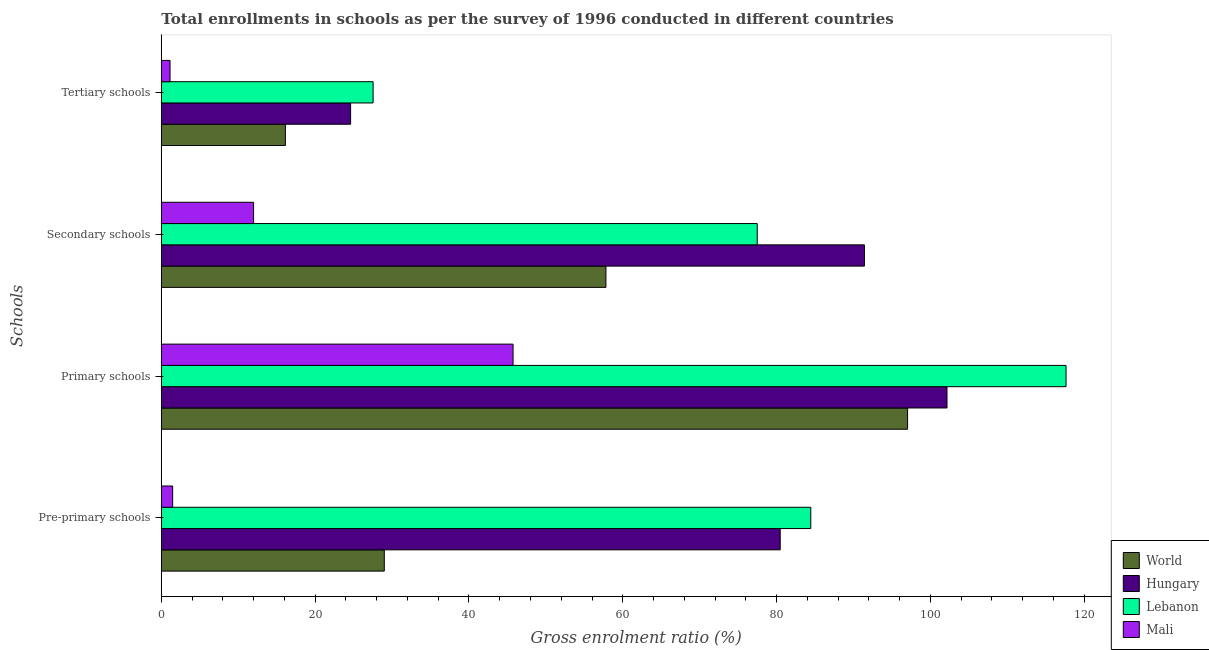How many groups of bars are there?
Provide a short and direct response. 4. Are the number of bars per tick equal to the number of legend labels?
Provide a short and direct response. Yes. Are the number of bars on each tick of the Y-axis equal?
Offer a terse response. Yes. How many bars are there on the 1st tick from the top?
Your answer should be very brief. 4. How many bars are there on the 1st tick from the bottom?
Give a very brief answer. 4. What is the label of the 2nd group of bars from the top?
Your response must be concise. Secondary schools. What is the gross enrolment ratio in primary schools in Hungary?
Provide a short and direct response. 102.16. Across all countries, what is the maximum gross enrolment ratio in secondary schools?
Offer a terse response. 91.43. Across all countries, what is the minimum gross enrolment ratio in primary schools?
Provide a short and direct response. 45.74. In which country was the gross enrolment ratio in tertiary schools maximum?
Make the answer very short. Lebanon. In which country was the gross enrolment ratio in tertiary schools minimum?
Provide a succinct answer. Mali. What is the total gross enrolment ratio in pre-primary schools in the graph?
Offer a very short reply. 195.39. What is the difference between the gross enrolment ratio in primary schools in Lebanon and that in Hungary?
Keep it short and to the point. 15.48. What is the difference between the gross enrolment ratio in primary schools in Mali and the gross enrolment ratio in pre-primary schools in Hungary?
Ensure brevity in your answer.  -34.74. What is the average gross enrolment ratio in pre-primary schools per country?
Keep it short and to the point. 48.85. What is the difference between the gross enrolment ratio in tertiary schools and gross enrolment ratio in primary schools in Hungary?
Your answer should be very brief. -77.54. In how many countries, is the gross enrolment ratio in pre-primary schools greater than 24 %?
Offer a terse response. 3. What is the ratio of the gross enrolment ratio in primary schools in Lebanon to that in Hungary?
Make the answer very short. 1.15. Is the gross enrolment ratio in secondary schools in World less than that in Hungary?
Provide a succinct answer. Yes. What is the difference between the highest and the second highest gross enrolment ratio in secondary schools?
Provide a succinct answer. 13.94. What is the difference between the highest and the lowest gross enrolment ratio in tertiary schools?
Offer a terse response. 26.4. In how many countries, is the gross enrolment ratio in primary schools greater than the average gross enrolment ratio in primary schools taken over all countries?
Make the answer very short. 3. Is it the case that in every country, the sum of the gross enrolment ratio in pre-primary schools and gross enrolment ratio in secondary schools is greater than the sum of gross enrolment ratio in tertiary schools and gross enrolment ratio in primary schools?
Give a very brief answer. No. What does the 3rd bar from the top in Secondary schools represents?
Offer a terse response. Hungary. What does the 3rd bar from the bottom in Pre-primary schools represents?
Keep it short and to the point. Lebanon. How many bars are there?
Your answer should be compact. 16. How many countries are there in the graph?
Make the answer very short. 4. What is the difference between two consecutive major ticks on the X-axis?
Offer a terse response. 20. Does the graph contain grids?
Offer a very short reply. No. Where does the legend appear in the graph?
Your answer should be very brief. Bottom right. How many legend labels are there?
Your response must be concise. 4. What is the title of the graph?
Make the answer very short. Total enrollments in schools as per the survey of 1996 conducted in different countries. Does "Serbia" appear as one of the legend labels in the graph?
Give a very brief answer. No. What is the label or title of the X-axis?
Ensure brevity in your answer.  Gross enrolment ratio (%). What is the label or title of the Y-axis?
Your response must be concise. Schools. What is the Gross enrolment ratio (%) in World in Pre-primary schools?
Offer a very short reply. 28.99. What is the Gross enrolment ratio (%) of Hungary in Pre-primary schools?
Offer a very short reply. 80.47. What is the Gross enrolment ratio (%) of Lebanon in Pre-primary schools?
Provide a short and direct response. 84.45. What is the Gross enrolment ratio (%) of Mali in Pre-primary schools?
Make the answer very short. 1.47. What is the Gross enrolment ratio (%) in World in Primary schools?
Offer a very short reply. 97.03. What is the Gross enrolment ratio (%) of Hungary in Primary schools?
Your response must be concise. 102.16. What is the Gross enrolment ratio (%) in Lebanon in Primary schools?
Offer a very short reply. 117.64. What is the Gross enrolment ratio (%) in Mali in Primary schools?
Your response must be concise. 45.74. What is the Gross enrolment ratio (%) of World in Secondary schools?
Your answer should be very brief. 57.81. What is the Gross enrolment ratio (%) of Hungary in Secondary schools?
Ensure brevity in your answer.  91.43. What is the Gross enrolment ratio (%) in Lebanon in Secondary schools?
Your answer should be compact. 77.48. What is the Gross enrolment ratio (%) in Mali in Secondary schools?
Make the answer very short. 11.99. What is the Gross enrolment ratio (%) of World in Tertiary schools?
Provide a short and direct response. 16.13. What is the Gross enrolment ratio (%) of Hungary in Tertiary schools?
Your response must be concise. 24.61. What is the Gross enrolment ratio (%) of Lebanon in Tertiary schools?
Offer a terse response. 27.54. What is the Gross enrolment ratio (%) of Mali in Tertiary schools?
Ensure brevity in your answer.  1.14. Across all Schools, what is the maximum Gross enrolment ratio (%) in World?
Provide a succinct answer. 97.03. Across all Schools, what is the maximum Gross enrolment ratio (%) of Hungary?
Give a very brief answer. 102.16. Across all Schools, what is the maximum Gross enrolment ratio (%) in Lebanon?
Provide a short and direct response. 117.64. Across all Schools, what is the maximum Gross enrolment ratio (%) of Mali?
Provide a short and direct response. 45.74. Across all Schools, what is the minimum Gross enrolment ratio (%) in World?
Keep it short and to the point. 16.13. Across all Schools, what is the minimum Gross enrolment ratio (%) in Hungary?
Make the answer very short. 24.61. Across all Schools, what is the minimum Gross enrolment ratio (%) in Lebanon?
Ensure brevity in your answer.  27.54. Across all Schools, what is the minimum Gross enrolment ratio (%) in Mali?
Provide a short and direct response. 1.14. What is the total Gross enrolment ratio (%) of World in the graph?
Give a very brief answer. 199.97. What is the total Gross enrolment ratio (%) in Hungary in the graph?
Provide a succinct answer. 298.67. What is the total Gross enrolment ratio (%) in Lebanon in the graph?
Your response must be concise. 307.11. What is the total Gross enrolment ratio (%) of Mali in the graph?
Your answer should be very brief. 60.34. What is the difference between the Gross enrolment ratio (%) in World in Pre-primary schools and that in Primary schools?
Your answer should be very brief. -68.04. What is the difference between the Gross enrolment ratio (%) in Hungary in Pre-primary schools and that in Primary schools?
Offer a terse response. -21.69. What is the difference between the Gross enrolment ratio (%) in Lebanon in Pre-primary schools and that in Primary schools?
Give a very brief answer. -33.19. What is the difference between the Gross enrolment ratio (%) in Mali in Pre-primary schools and that in Primary schools?
Provide a succinct answer. -44.26. What is the difference between the Gross enrolment ratio (%) of World in Pre-primary schools and that in Secondary schools?
Provide a succinct answer. -28.82. What is the difference between the Gross enrolment ratio (%) of Hungary in Pre-primary schools and that in Secondary schools?
Make the answer very short. -10.95. What is the difference between the Gross enrolment ratio (%) in Lebanon in Pre-primary schools and that in Secondary schools?
Your answer should be very brief. 6.96. What is the difference between the Gross enrolment ratio (%) of Mali in Pre-primary schools and that in Secondary schools?
Offer a terse response. -10.52. What is the difference between the Gross enrolment ratio (%) in World in Pre-primary schools and that in Tertiary schools?
Your answer should be very brief. 12.86. What is the difference between the Gross enrolment ratio (%) of Hungary in Pre-primary schools and that in Tertiary schools?
Give a very brief answer. 55.86. What is the difference between the Gross enrolment ratio (%) of Lebanon in Pre-primary schools and that in Tertiary schools?
Your answer should be compact. 56.91. What is the difference between the Gross enrolment ratio (%) of Mali in Pre-primary schools and that in Tertiary schools?
Make the answer very short. 0.34. What is the difference between the Gross enrolment ratio (%) in World in Primary schools and that in Secondary schools?
Your response must be concise. 39.22. What is the difference between the Gross enrolment ratio (%) in Hungary in Primary schools and that in Secondary schools?
Offer a very short reply. 10.73. What is the difference between the Gross enrolment ratio (%) in Lebanon in Primary schools and that in Secondary schools?
Your answer should be compact. 40.15. What is the difference between the Gross enrolment ratio (%) in Mali in Primary schools and that in Secondary schools?
Offer a very short reply. 33.74. What is the difference between the Gross enrolment ratio (%) of World in Primary schools and that in Tertiary schools?
Your answer should be compact. 80.9. What is the difference between the Gross enrolment ratio (%) of Hungary in Primary schools and that in Tertiary schools?
Offer a very short reply. 77.54. What is the difference between the Gross enrolment ratio (%) in Lebanon in Primary schools and that in Tertiary schools?
Offer a very short reply. 90.1. What is the difference between the Gross enrolment ratio (%) in Mali in Primary schools and that in Tertiary schools?
Your answer should be very brief. 44.6. What is the difference between the Gross enrolment ratio (%) in World in Secondary schools and that in Tertiary schools?
Your answer should be very brief. 41.68. What is the difference between the Gross enrolment ratio (%) of Hungary in Secondary schools and that in Tertiary schools?
Your response must be concise. 66.81. What is the difference between the Gross enrolment ratio (%) of Lebanon in Secondary schools and that in Tertiary schools?
Provide a short and direct response. 49.95. What is the difference between the Gross enrolment ratio (%) in Mali in Secondary schools and that in Tertiary schools?
Your answer should be very brief. 10.86. What is the difference between the Gross enrolment ratio (%) in World in Pre-primary schools and the Gross enrolment ratio (%) in Hungary in Primary schools?
Offer a terse response. -73.16. What is the difference between the Gross enrolment ratio (%) in World in Pre-primary schools and the Gross enrolment ratio (%) in Lebanon in Primary schools?
Give a very brief answer. -88.64. What is the difference between the Gross enrolment ratio (%) in World in Pre-primary schools and the Gross enrolment ratio (%) in Mali in Primary schools?
Your answer should be very brief. -16.74. What is the difference between the Gross enrolment ratio (%) of Hungary in Pre-primary schools and the Gross enrolment ratio (%) of Lebanon in Primary schools?
Make the answer very short. -37.17. What is the difference between the Gross enrolment ratio (%) of Hungary in Pre-primary schools and the Gross enrolment ratio (%) of Mali in Primary schools?
Make the answer very short. 34.74. What is the difference between the Gross enrolment ratio (%) of Lebanon in Pre-primary schools and the Gross enrolment ratio (%) of Mali in Primary schools?
Provide a short and direct response. 38.71. What is the difference between the Gross enrolment ratio (%) of World in Pre-primary schools and the Gross enrolment ratio (%) of Hungary in Secondary schools?
Keep it short and to the point. -62.43. What is the difference between the Gross enrolment ratio (%) in World in Pre-primary schools and the Gross enrolment ratio (%) in Lebanon in Secondary schools?
Make the answer very short. -48.49. What is the difference between the Gross enrolment ratio (%) in World in Pre-primary schools and the Gross enrolment ratio (%) in Mali in Secondary schools?
Make the answer very short. 17. What is the difference between the Gross enrolment ratio (%) of Hungary in Pre-primary schools and the Gross enrolment ratio (%) of Lebanon in Secondary schools?
Make the answer very short. 2.99. What is the difference between the Gross enrolment ratio (%) in Hungary in Pre-primary schools and the Gross enrolment ratio (%) in Mali in Secondary schools?
Your answer should be very brief. 68.48. What is the difference between the Gross enrolment ratio (%) in Lebanon in Pre-primary schools and the Gross enrolment ratio (%) in Mali in Secondary schools?
Provide a short and direct response. 72.45. What is the difference between the Gross enrolment ratio (%) in World in Pre-primary schools and the Gross enrolment ratio (%) in Hungary in Tertiary schools?
Make the answer very short. 4.38. What is the difference between the Gross enrolment ratio (%) in World in Pre-primary schools and the Gross enrolment ratio (%) in Lebanon in Tertiary schools?
Provide a short and direct response. 1.46. What is the difference between the Gross enrolment ratio (%) of World in Pre-primary schools and the Gross enrolment ratio (%) of Mali in Tertiary schools?
Keep it short and to the point. 27.86. What is the difference between the Gross enrolment ratio (%) in Hungary in Pre-primary schools and the Gross enrolment ratio (%) in Lebanon in Tertiary schools?
Provide a short and direct response. 52.93. What is the difference between the Gross enrolment ratio (%) in Hungary in Pre-primary schools and the Gross enrolment ratio (%) in Mali in Tertiary schools?
Ensure brevity in your answer.  79.34. What is the difference between the Gross enrolment ratio (%) in Lebanon in Pre-primary schools and the Gross enrolment ratio (%) in Mali in Tertiary schools?
Give a very brief answer. 83.31. What is the difference between the Gross enrolment ratio (%) in World in Primary schools and the Gross enrolment ratio (%) in Hungary in Secondary schools?
Keep it short and to the point. 5.61. What is the difference between the Gross enrolment ratio (%) in World in Primary schools and the Gross enrolment ratio (%) in Lebanon in Secondary schools?
Provide a short and direct response. 19.55. What is the difference between the Gross enrolment ratio (%) in World in Primary schools and the Gross enrolment ratio (%) in Mali in Secondary schools?
Your answer should be very brief. 85.04. What is the difference between the Gross enrolment ratio (%) of Hungary in Primary schools and the Gross enrolment ratio (%) of Lebanon in Secondary schools?
Provide a succinct answer. 24.67. What is the difference between the Gross enrolment ratio (%) of Hungary in Primary schools and the Gross enrolment ratio (%) of Mali in Secondary schools?
Offer a very short reply. 90.16. What is the difference between the Gross enrolment ratio (%) of Lebanon in Primary schools and the Gross enrolment ratio (%) of Mali in Secondary schools?
Ensure brevity in your answer.  105.64. What is the difference between the Gross enrolment ratio (%) in World in Primary schools and the Gross enrolment ratio (%) in Hungary in Tertiary schools?
Ensure brevity in your answer.  72.42. What is the difference between the Gross enrolment ratio (%) in World in Primary schools and the Gross enrolment ratio (%) in Lebanon in Tertiary schools?
Provide a short and direct response. 69.5. What is the difference between the Gross enrolment ratio (%) of World in Primary schools and the Gross enrolment ratio (%) of Mali in Tertiary schools?
Your answer should be very brief. 95.9. What is the difference between the Gross enrolment ratio (%) of Hungary in Primary schools and the Gross enrolment ratio (%) of Lebanon in Tertiary schools?
Your answer should be compact. 74.62. What is the difference between the Gross enrolment ratio (%) in Hungary in Primary schools and the Gross enrolment ratio (%) in Mali in Tertiary schools?
Your answer should be compact. 101.02. What is the difference between the Gross enrolment ratio (%) of Lebanon in Primary schools and the Gross enrolment ratio (%) of Mali in Tertiary schools?
Give a very brief answer. 116.5. What is the difference between the Gross enrolment ratio (%) of World in Secondary schools and the Gross enrolment ratio (%) of Hungary in Tertiary schools?
Give a very brief answer. 33.2. What is the difference between the Gross enrolment ratio (%) in World in Secondary schools and the Gross enrolment ratio (%) in Lebanon in Tertiary schools?
Offer a very short reply. 30.27. What is the difference between the Gross enrolment ratio (%) in World in Secondary schools and the Gross enrolment ratio (%) in Mali in Tertiary schools?
Make the answer very short. 56.68. What is the difference between the Gross enrolment ratio (%) in Hungary in Secondary schools and the Gross enrolment ratio (%) in Lebanon in Tertiary schools?
Offer a very short reply. 63.89. What is the difference between the Gross enrolment ratio (%) of Hungary in Secondary schools and the Gross enrolment ratio (%) of Mali in Tertiary schools?
Provide a short and direct response. 90.29. What is the difference between the Gross enrolment ratio (%) of Lebanon in Secondary schools and the Gross enrolment ratio (%) of Mali in Tertiary schools?
Provide a succinct answer. 76.35. What is the average Gross enrolment ratio (%) in World per Schools?
Keep it short and to the point. 49.99. What is the average Gross enrolment ratio (%) of Hungary per Schools?
Your answer should be compact. 74.67. What is the average Gross enrolment ratio (%) in Lebanon per Schools?
Your answer should be very brief. 76.78. What is the average Gross enrolment ratio (%) of Mali per Schools?
Offer a terse response. 15.08. What is the difference between the Gross enrolment ratio (%) in World and Gross enrolment ratio (%) in Hungary in Pre-primary schools?
Provide a short and direct response. -51.48. What is the difference between the Gross enrolment ratio (%) of World and Gross enrolment ratio (%) of Lebanon in Pre-primary schools?
Provide a succinct answer. -55.45. What is the difference between the Gross enrolment ratio (%) in World and Gross enrolment ratio (%) in Mali in Pre-primary schools?
Your response must be concise. 27.52. What is the difference between the Gross enrolment ratio (%) in Hungary and Gross enrolment ratio (%) in Lebanon in Pre-primary schools?
Make the answer very short. -3.98. What is the difference between the Gross enrolment ratio (%) in Hungary and Gross enrolment ratio (%) in Mali in Pre-primary schools?
Provide a succinct answer. 79. What is the difference between the Gross enrolment ratio (%) in Lebanon and Gross enrolment ratio (%) in Mali in Pre-primary schools?
Your answer should be very brief. 82.97. What is the difference between the Gross enrolment ratio (%) in World and Gross enrolment ratio (%) in Hungary in Primary schools?
Your answer should be compact. -5.12. What is the difference between the Gross enrolment ratio (%) in World and Gross enrolment ratio (%) in Lebanon in Primary schools?
Keep it short and to the point. -20.6. What is the difference between the Gross enrolment ratio (%) of World and Gross enrolment ratio (%) of Mali in Primary schools?
Give a very brief answer. 51.3. What is the difference between the Gross enrolment ratio (%) in Hungary and Gross enrolment ratio (%) in Lebanon in Primary schools?
Give a very brief answer. -15.48. What is the difference between the Gross enrolment ratio (%) of Hungary and Gross enrolment ratio (%) of Mali in Primary schools?
Make the answer very short. 56.42. What is the difference between the Gross enrolment ratio (%) of Lebanon and Gross enrolment ratio (%) of Mali in Primary schools?
Offer a terse response. 71.9. What is the difference between the Gross enrolment ratio (%) of World and Gross enrolment ratio (%) of Hungary in Secondary schools?
Provide a succinct answer. -33.61. What is the difference between the Gross enrolment ratio (%) of World and Gross enrolment ratio (%) of Lebanon in Secondary schools?
Provide a succinct answer. -19.67. What is the difference between the Gross enrolment ratio (%) in World and Gross enrolment ratio (%) in Mali in Secondary schools?
Provide a succinct answer. 45.82. What is the difference between the Gross enrolment ratio (%) in Hungary and Gross enrolment ratio (%) in Lebanon in Secondary schools?
Offer a terse response. 13.94. What is the difference between the Gross enrolment ratio (%) in Hungary and Gross enrolment ratio (%) in Mali in Secondary schools?
Your answer should be very brief. 79.43. What is the difference between the Gross enrolment ratio (%) of Lebanon and Gross enrolment ratio (%) of Mali in Secondary schools?
Provide a succinct answer. 65.49. What is the difference between the Gross enrolment ratio (%) of World and Gross enrolment ratio (%) of Hungary in Tertiary schools?
Keep it short and to the point. -8.48. What is the difference between the Gross enrolment ratio (%) of World and Gross enrolment ratio (%) of Lebanon in Tertiary schools?
Your answer should be compact. -11.41. What is the difference between the Gross enrolment ratio (%) in World and Gross enrolment ratio (%) in Mali in Tertiary schools?
Ensure brevity in your answer.  15. What is the difference between the Gross enrolment ratio (%) in Hungary and Gross enrolment ratio (%) in Lebanon in Tertiary schools?
Give a very brief answer. -2.92. What is the difference between the Gross enrolment ratio (%) of Hungary and Gross enrolment ratio (%) of Mali in Tertiary schools?
Provide a short and direct response. 23.48. What is the difference between the Gross enrolment ratio (%) of Lebanon and Gross enrolment ratio (%) of Mali in Tertiary schools?
Keep it short and to the point. 26.4. What is the ratio of the Gross enrolment ratio (%) in World in Pre-primary schools to that in Primary schools?
Make the answer very short. 0.3. What is the ratio of the Gross enrolment ratio (%) in Hungary in Pre-primary schools to that in Primary schools?
Your answer should be compact. 0.79. What is the ratio of the Gross enrolment ratio (%) of Lebanon in Pre-primary schools to that in Primary schools?
Your response must be concise. 0.72. What is the ratio of the Gross enrolment ratio (%) in Mali in Pre-primary schools to that in Primary schools?
Offer a terse response. 0.03. What is the ratio of the Gross enrolment ratio (%) in World in Pre-primary schools to that in Secondary schools?
Ensure brevity in your answer.  0.5. What is the ratio of the Gross enrolment ratio (%) in Hungary in Pre-primary schools to that in Secondary schools?
Offer a terse response. 0.88. What is the ratio of the Gross enrolment ratio (%) in Lebanon in Pre-primary schools to that in Secondary schools?
Provide a succinct answer. 1.09. What is the ratio of the Gross enrolment ratio (%) in Mali in Pre-primary schools to that in Secondary schools?
Give a very brief answer. 0.12. What is the ratio of the Gross enrolment ratio (%) of World in Pre-primary schools to that in Tertiary schools?
Give a very brief answer. 1.8. What is the ratio of the Gross enrolment ratio (%) of Hungary in Pre-primary schools to that in Tertiary schools?
Offer a very short reply. 3.27. What is the ratio of the Gross enrolment ratio (%) in Lebanon in Pre-primary schools to that in Tertiary schools?
Provide a short and direct response. 3.07. What is the ratio of the Gross enrolment ratio (%) in Mali in Pre-primary schools to that in Tertiary schools?
Give a very brief answer. 1.3. What is the ratio of the Gross enrolment ratio (%) in World in Primary schools to that in Secondary schools?
Keep it short and to the point. 1.68. What is the ratio of the Gross enrolment ratio (%) in Hungary in Primary schools to that in Secondary schools?
Your answer should be very brief. 1.12. What is the ratio of the Gross enrolment ratio (%) of Lebanon in Primary schools to that in Secondary schools?
Provide a short and direct response. 1.52. What is the ratio of the Gross enrolment ratio (%) in Mali in Primary schools to that in Secondary schools?
Provide a short and direct response. 3.81. What is the ratio of the Gross enrolment ratio (%) of World in Primary schools to that in Tertiary schools?
Your answer should be very brief. 6.02. What is the ratio of the Gross enrolment ratio (%) of Hungary in Primary schools to that in Tertiary schools?
Make the answer very short. 4.15. What is the ratio of the Gross enrolment ratio (%) of Lebanon in Primary schools to that in Tertiary schools?
Ensure brevity in your answer.  4.27. What is the ratio of the Gross enrolment ratio (%) in Mali in Primary schools to that in Tertiary schools?
Offer a very short reply. 40.29. What is the ratio of the Gross enrolment ratio (%) of World in Secondary schools to that in Tertiary schools?
Your answer should be very brief. 3.58. What is the ratio of the Gross enrolment ratio (%) of Hungary in Secondary schools to that in Tertiary schools?
Make the answer very short. 3.71. What is the ratio of the Gross enrolment ratio (%) in Lebanon in Secondary schools to that in Tertiary schools?
Provide a short and direct response. 2.81. What is the ratio of the Gross enrolment ratio (%) of Mali in Secondary schools to that in Tertiary schools?
Offer a very short reply. 10.57. What is the difference between the highest and the second highest Gross enrolment ratio (%) in World?
Make the answer very short. 39.22. What is the difference between the highest and the second highest Gross enrolment ratio (%) in Hungary?
Ensure brevity in your answer.  10.73. What is the difference between the highest and the second highest Gross enrolment ratio (%) in Lebanon?
Ensure brevity in your answer.  33.19. What is the difference between the highest and the second highest Gross enrolment ratio (%) of Mali?
Provide a succinct answer. 33.74. What is the difference between the highest and the lowest Gross enrolment ratio (%) of World?
Make the answer very short. 80.9. What is the difference between the highest and the lowest Gross enrolment ratio (%) of Hungary?
Offer a terse response. 77.54. What is the difference between the highest and the lowest Gross enrolment ratio (%) of Lebanon?
Offer a very short reply. 90.1. What is the difference between the highest and the lowest Gross enrolment ratio (%) of Mali?
Offer a terse response. 44.6. 